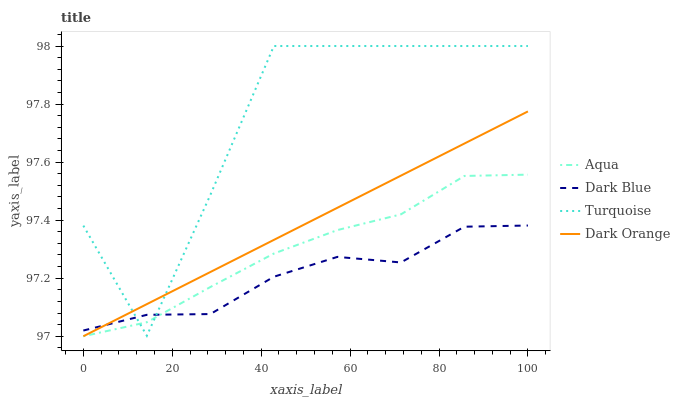Does Dark Blue have the minimum area under the curve?
Answer yes or no. Yes. Does Turquoise have the maximum area under the curve?
Answer yes or no. Yes. Does Aqua have the minimum area under the curve?
Answer yes or no. No. Does Aqua have the maximum area under the curve?
Answer yes or no. No. Is Dark Orange the smoothest?
Answer yes or no. Yes. Is Turquoise the roughest?
Answer yes or no. Yes. Is Aqua the smoothest?
Answer yes or no. No. Is Aqua the roughest?
Answer yes or no. No. Does Turquoise have the lowest value?
Answer yes or no. No. Does Turquoise have the highest value?
Answer yes or no. Yes. Does Aqua have the highest value?
Answer yes or no. No. Does Aqua intersect Dark Orange?
Answer yes or no. Yes. Is Aqua less than Dark Orange?
Answer yes or no. No. Is Aqua greater than Dark Orange?
Answer yes or no. No. 